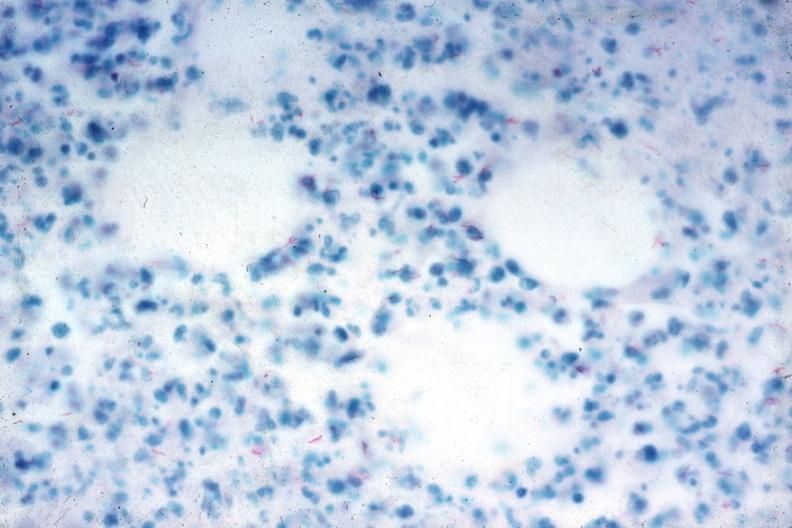s nodular tumor present?
Answer the question using a single word or phrase. No 